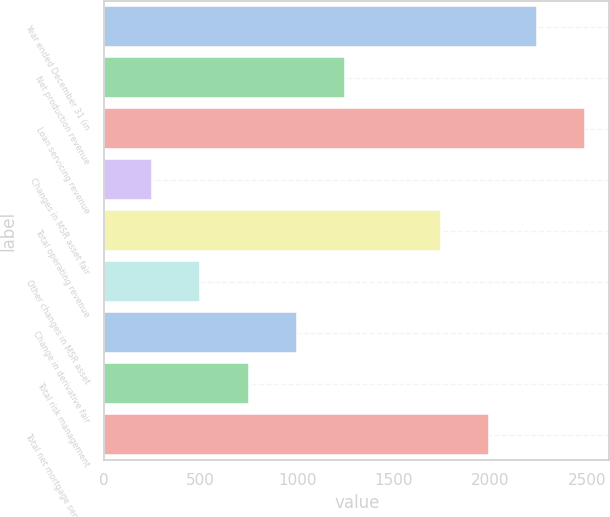<chart> <loc_0><loc_0><loc_500><loc_500><bar_chart><fcel>Year ended December 31 (in<fcel>Net production revenue<fcel>Loan servicing revenue<fcel>Changes in MSR asset fair<fcel>Total operating revenue<fcel>Other changes in MSR asset<fcel>Change in derivative fair<fcel>Total risk management<fcel>Total net mortgage servicing<nl><fcel>2242<fcel>1246<fcel>2491<fcel>250<fcel>1744<fcel>499<fcel>997<fcel>748<fcel>1993<nl></chart> 